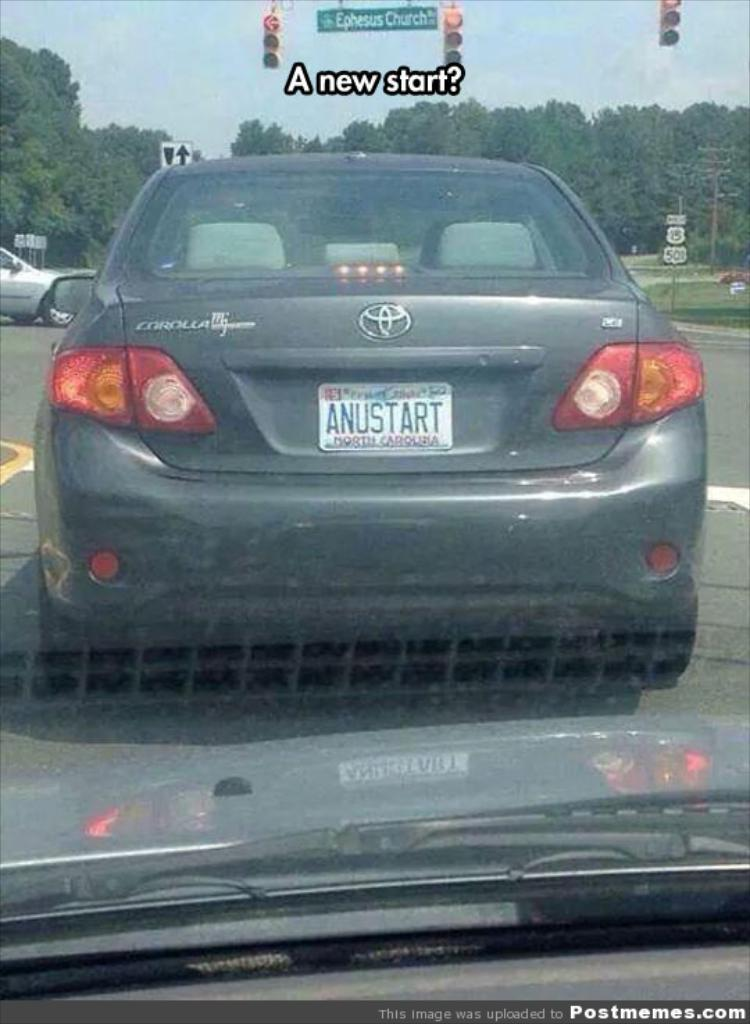<image>
Relay a brief, clear account of the picture shown. the backend of a grey corolla with licence plate ANUSTART 